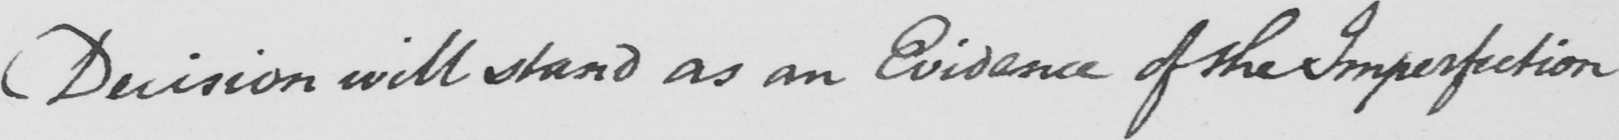What is written in this line of handwriting? Decision will stand as an Evidence of the Imperfection 